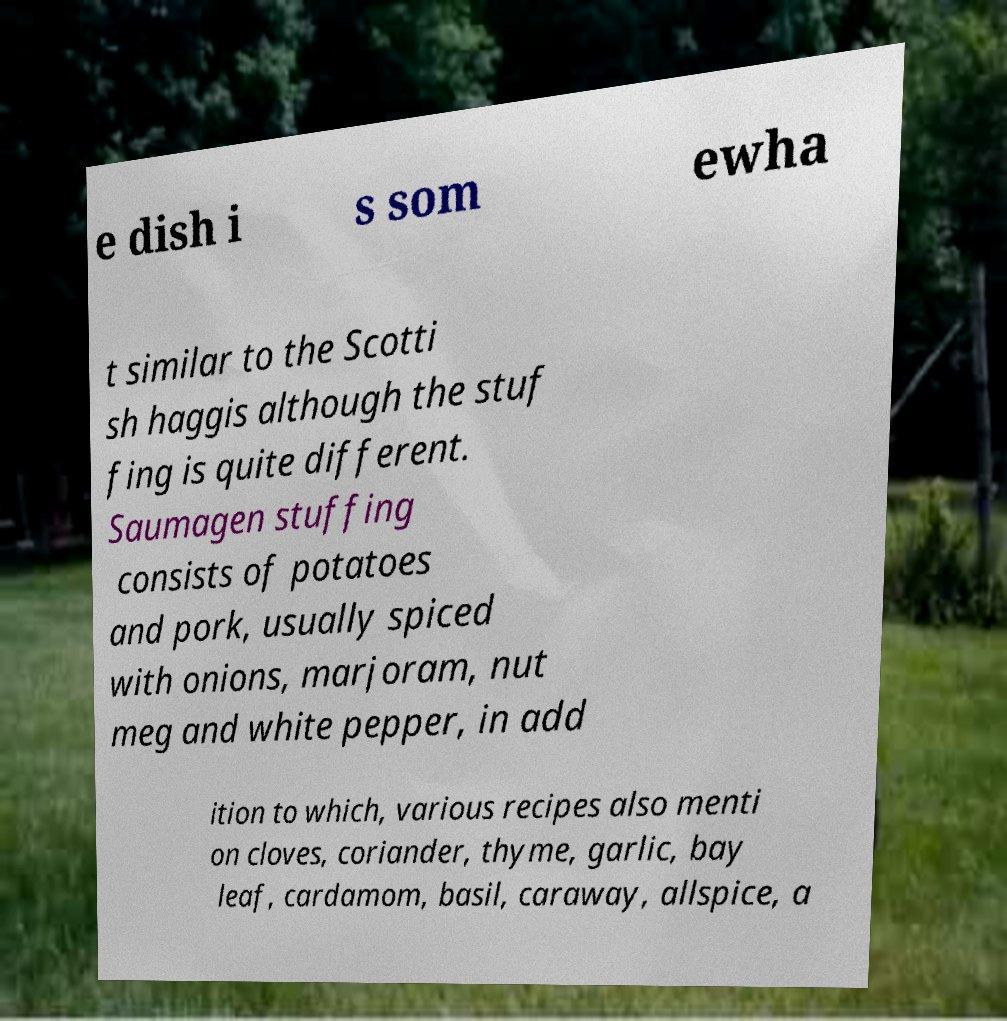Please read and relay the text visible in this image. What does it say? e dish i s som ewha t similar to the Scotti sh haggis although the stuf fing is quite different. Saumagen stuffing consists of potatoes and pork, usually spiced with onions, marjoram, nut meg and white pepper, in add ition to which, various recipes also menti on cloves, coriander, thyme, garlic, bay leaf, cardamom, basil, caraway, allspice, a 